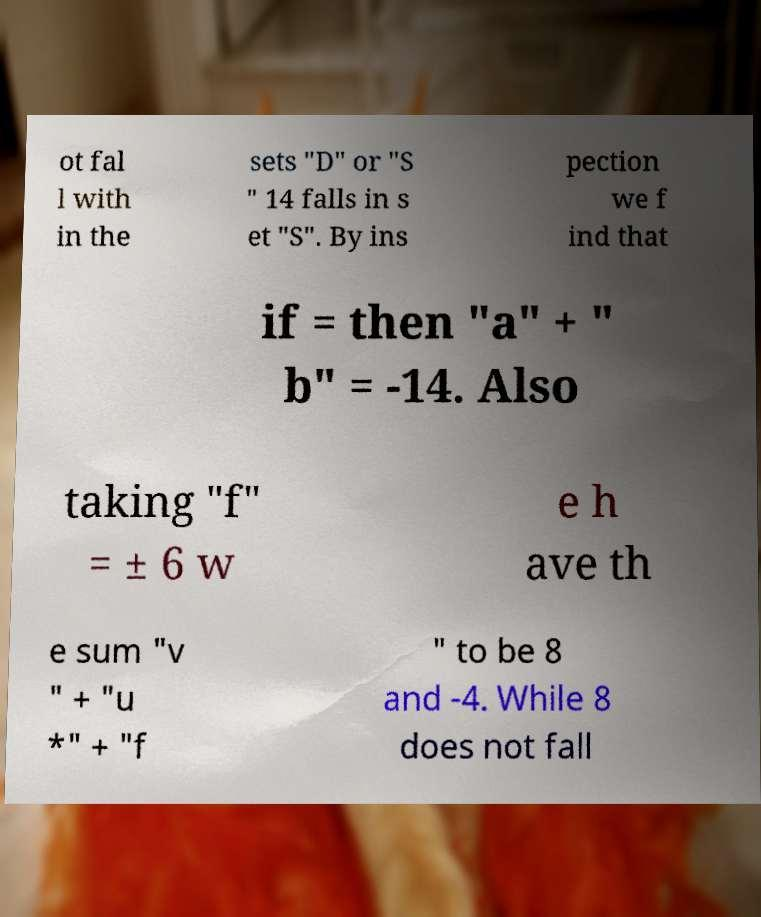Can you accurately transcribe the text from the provided image for me? ot fal l with in the sets "D" or "S " 14 falls in s et "S". By ins pection we f ind that if = then "a" + " b" = -14. Also taking "f" = ± 6 w e h ave th e sum "v " + "u *" + "f " to be 8 and -4. While 8 does not fall 